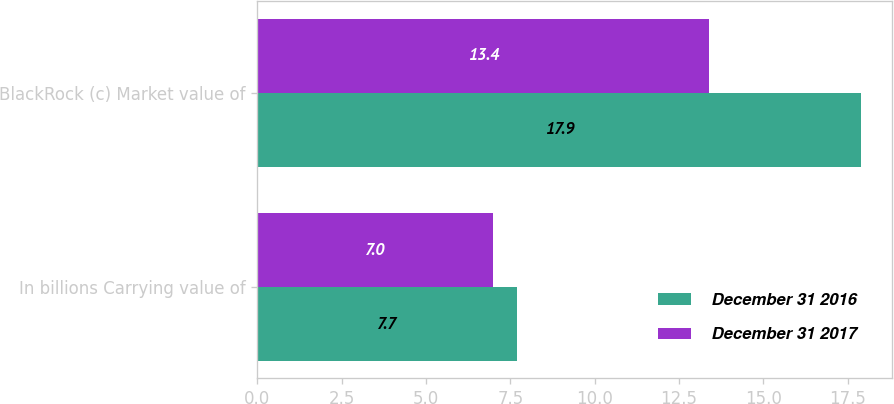<chart> <loc_0><loc_0><loc_500><loc_500><stacked_bar_chart><ecel><fcel>In billions Carrying value of<fcel>BlackRock (c) Market value of<nl><fcel>December 31 2016<fcel>7.7<fcel>17.9<nl><fcel>December 31 2017<fcel>7<fcel>13.4<nl></chart> 